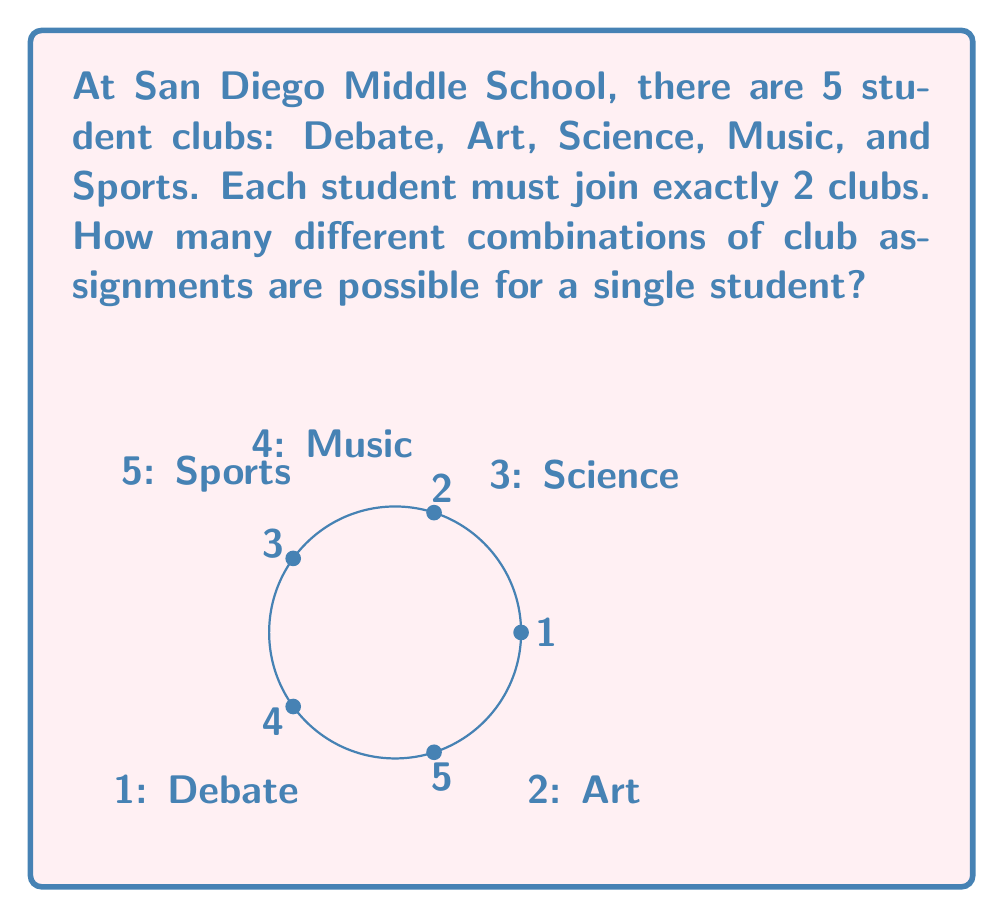Solve this math problem. To solve this problem, we need to use the combination formula. Here's the step-by-step explanation:

1) We are choosing 2 clubs out of 5 available clubs. This is a combination problem because the order doesn't matter (joining Debate and Art is the same as joining Art and Debate).

2) The formula for combinations is:

   $$C(n,r) = \frac{n!}{r!(n-r)!}$$

   Where $n$ is the total number of items to choose from, and $r$ is the number of items being chosen.

3) In this case, $n = 5$ (total number of clubs) and $r = 2$ (number of clubs each student joins).

4) Let's substitute these values into the formula:

   $$C(5,2) = \frac{5!}{2!(5-2)!} = \frac{5!}{2!(3)!}$$

5) Expand this:
   $$\frac{5 \times 4 \times 3!}{2 \times 1 \times 3!}$$

6) The $3!$ cancels out in the numerator and denominator:

   $$\frac{5 \times 4}{2 \times 1} = \frac{20}{2} = 10$$

Therefore, there are 10 possible combinations of club assignments for a single student.
Answer: 10 